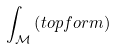Convert formula to latex. <formula><loc_0><loc_0><loc_500><loc_500>\int _ { \mathcal { M } } \left ( t o p f o r m \right )</formula> 